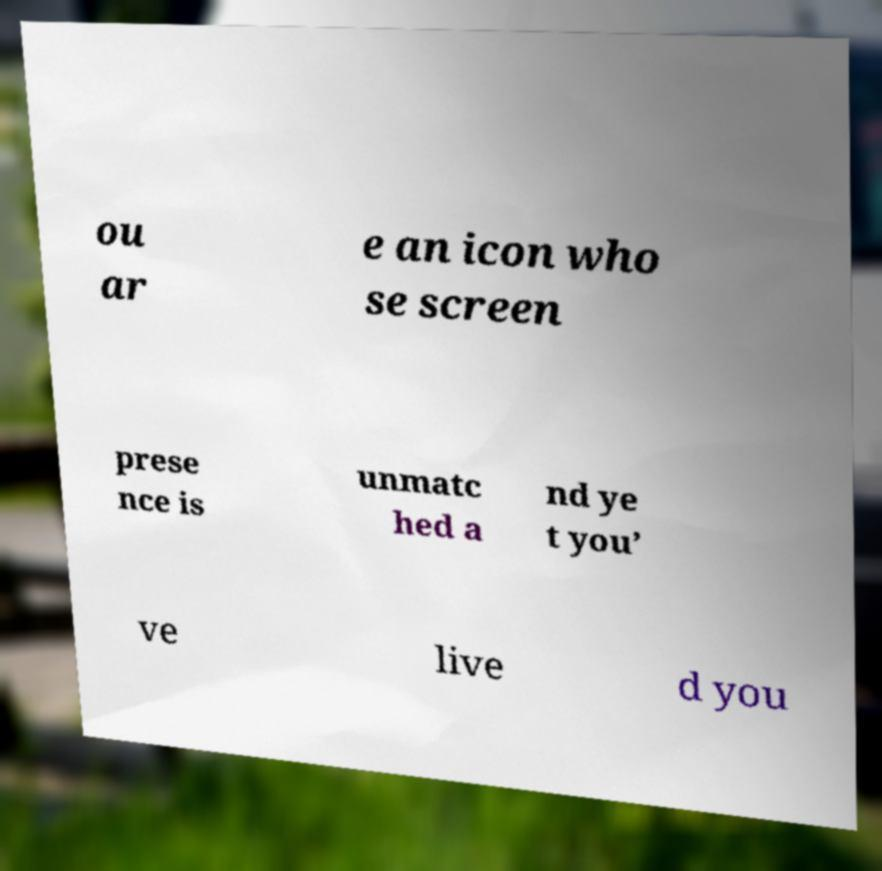Please identify and transcribe the text found in this image. ou ar e an icon who se screen prese nce is unmatc hed a nd ye t you’ ve live d you 